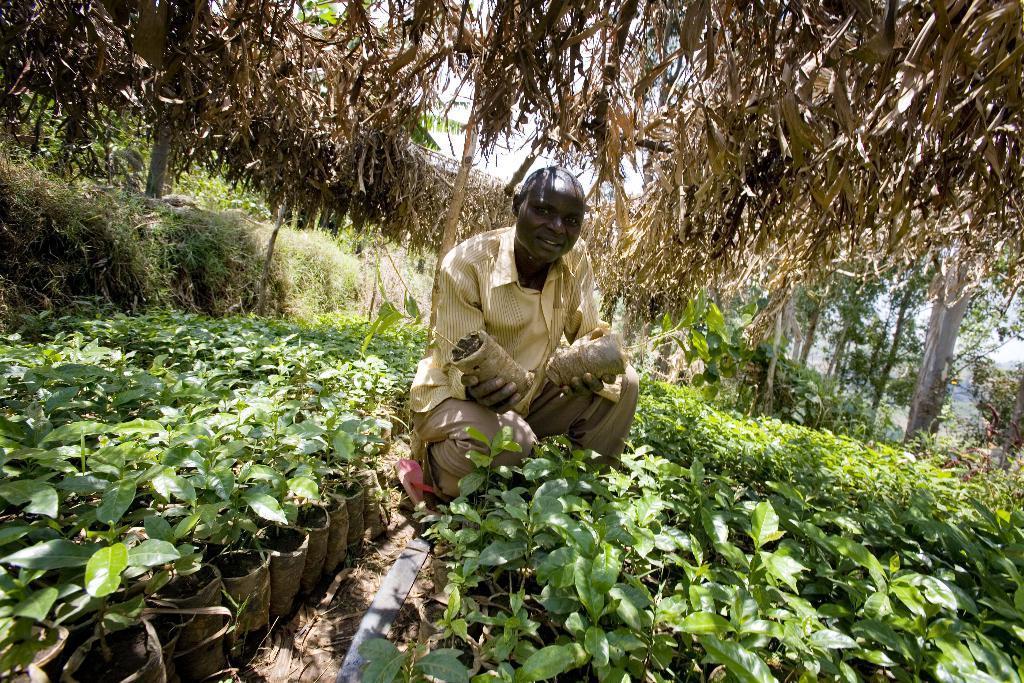Could you give a brief overview of what you see in this image? In the foreground of this picture, there is a man squatting and there are plants around him. On the top, there are dried leaves. In the background, we can see the greenery and the sky. 